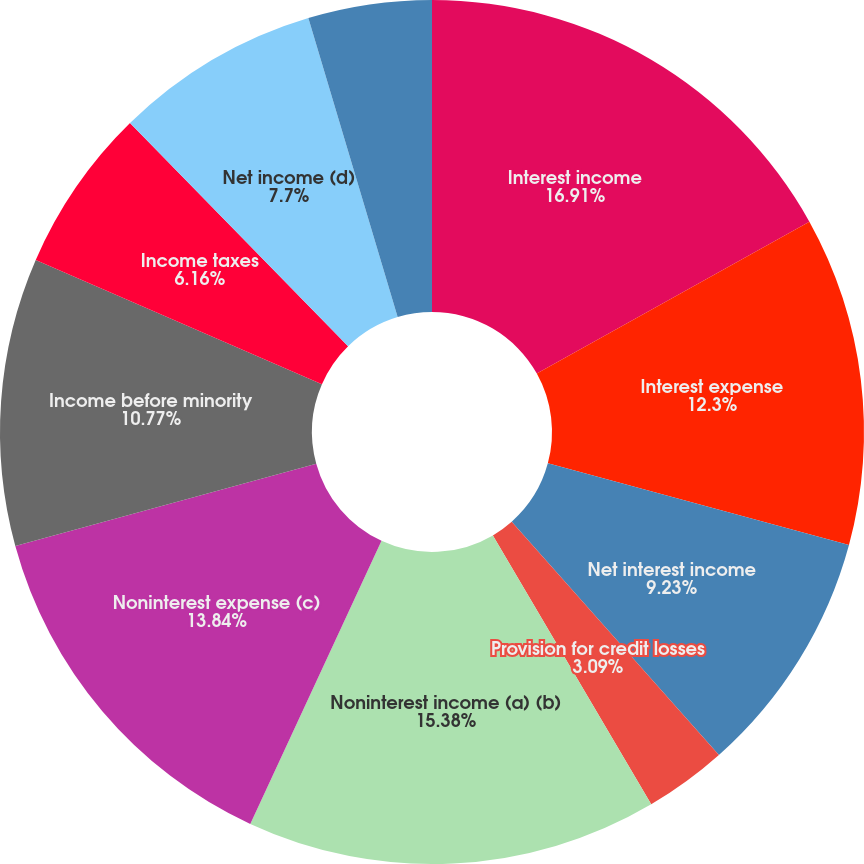Convert chart to OTSL. <chart><loc_0><loc_0><loc_500><loc_500><pie_chart><fcel>Interest income<fcel>Interest expense<fcel>Net interest income<fcel>Provision for credit losses<fcel>Noninterest income (a) (b)<fcel>Noninterest expense (c)<fcel>Income before minority<fcel>Income taxes<fcel>Net income (d)<fcel>Book value<nl><fcel>16.91%<fcel>12.3%<fcel>9.23%<fcel>3.09%<fcel>15.38%<fcel>13.84%<fcel>10.77%<fcel>6.16%<fcel>7.7%<fcel>4.62%<nl></chart> 